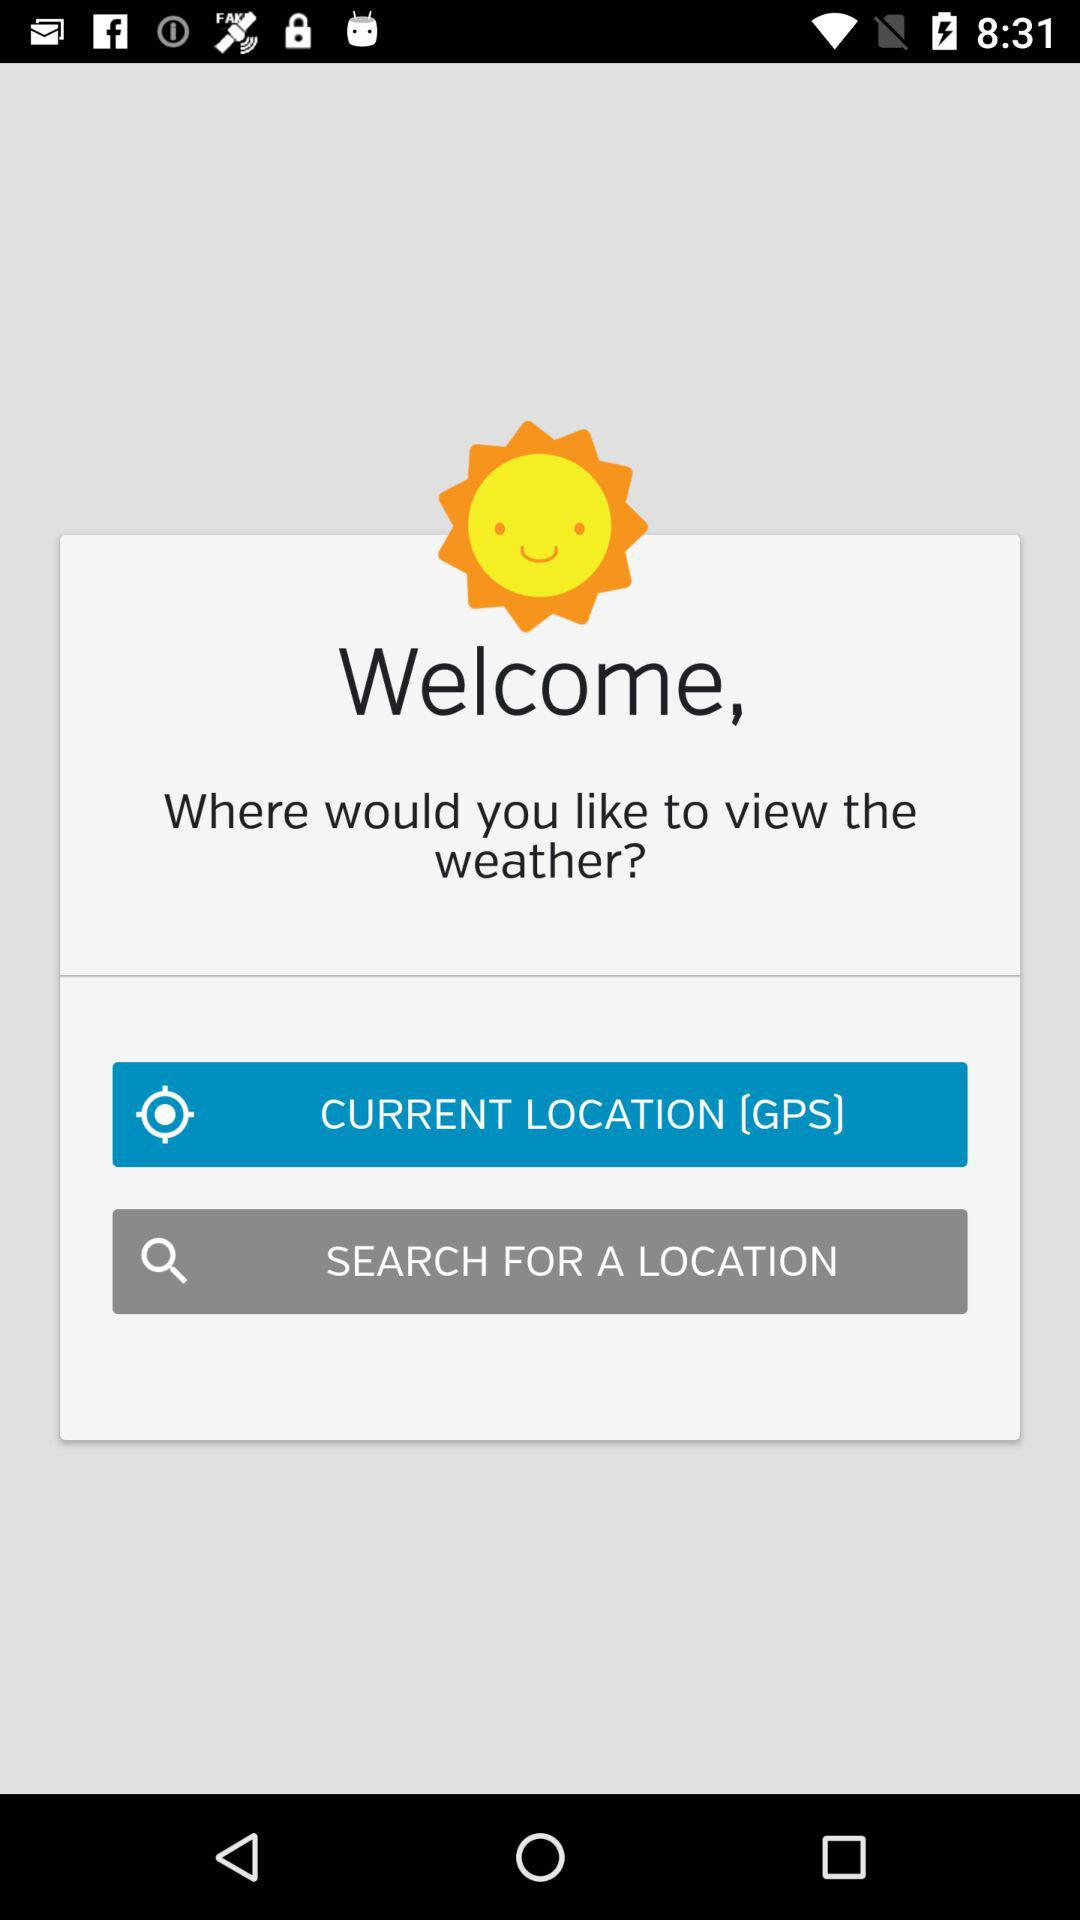Where is the user located?
When the provided information is insufficient, respond with <no answer>. <no answer> 